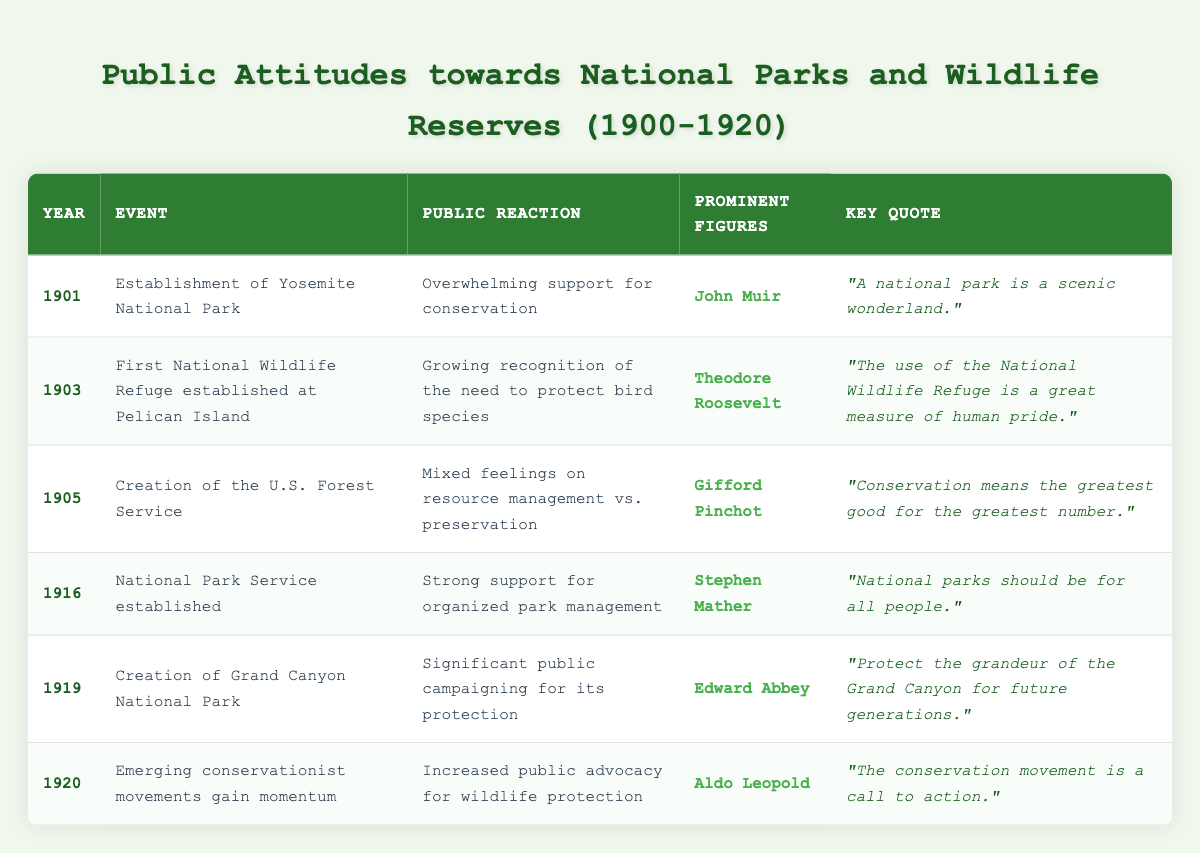What year was Yosemite National Park established? The table lists the establishment of Yosemite National Park in the year 1901.
Answer: 1901 Which prominent figure is associated with the establishment of the Yosemite National Park? According to the table, John Muir is the prominent figure associated with the establishment of Yosemite National Park.
Answer: John Muir What was the public reaction to the creation of the U.S. Forest Service in 1905? The table indicates that the public reaction was characterized by mixed feelings about resource management versus preservation.
Answer: Mixed feelings on resource management vs. preservation How many significant events related to conservation occurred between 1901 and 1920? The table lists six significant events related to conservation within the specified timeframe; they are highlighted in the data.
Answer: Six What key quote was associated with the establishment of the National Park Service in 1916? The key quote from the establishment of the National Park Service in 1916 was "National parks should be for all people."
Answer: "National parks should be for all people." Did public reactions to the events from 1916 onward predominantly show strong advocacy for wildlife protection? Yes, the reactions from 1916 onward indicate a trend of strong public support and advocacy for wildlife protection.
Answer: Yes What is the difference between the year when Yosemite National Park and Grand Canyon National Park were established? Yosemite National Park was established in 1901, and Grand Canyon National Park was established in 1919. The difference is 1919 - 1901 = 18 years.
Answer: 18 years Which prominent figure is quoted aboutthe importance of the Grand Canyon's protection and what is the essence of their message? Edward Abbey is quoted on protecting the Grand Canyon, emphasizing the need to safeguard its grandeur for future generations.
Answer: Edward Abbey; Protect the Grand Canyon for future generations What was the primary public sentiment in 1920 related to wildlife protection? The table states that in 1920 there was increased public advocacy for wildlife protection, as noted in the public reaction.
Answer: Increased public advocacy for wildlife protection Which event in 1903 reflects a growing recognition of the need for bird species protection? The first National Wildlife Refuge established at Pelican Island in 1903 reflects that growing recognition, as indicated in the table.
Answer: First National Wildlife Refuge at Pelican Island Summarize the trend in public attitudes toward conservation from the establishment of Yosemite National Park in 1901 to the conservationist movements in 1920. Throughout the years, public attitudes shifted from overwhelming support for conservation to significant campaigning for specific protections such as wildlife and national parks, culminating in organized movements and increased advocacy by 1920.
Answer: Shift from overwhelming support to organized advocacy 